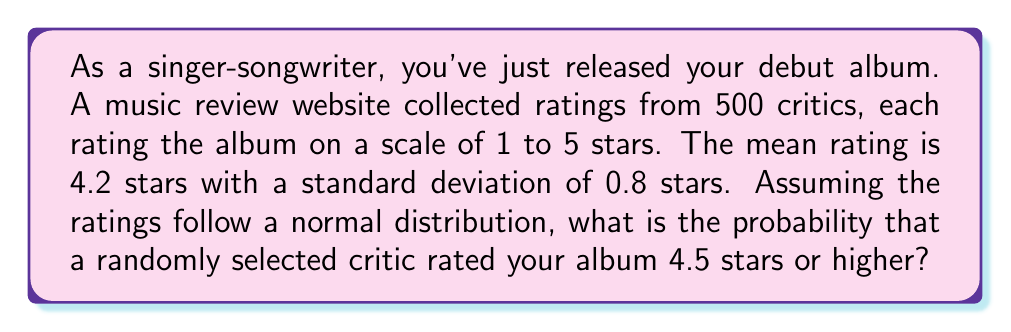Solve this math problem. To solve this problem, we'll use the properties of the normal distribution and the z-score formula. Here's a step-by-step approach:

1. Identify the given information:
   - Mean (μ) = 4.2 stars
   - Standard deviation (σ) = 0.8 stars
   - We want to find P(X ≥ 4.5), where X is the rating

2. Calculate the z-score for 4.5 stars:
   $$z = \frac{x - \mu}{\sigma} = \frac{4.5 - 4.2}{0.8} = 0.375$$

3. Use the standard normal distribution table or a calculator to find the area to the right of z = 0.375:
   P(Z > 0.375) = 1 - P(Z < 0.375)
   
   From the standard normal table:
   P(Z < 0.375) ≈ 0.6462

   Therefore:
   P(Z > 0.375) = 1 - 0.6462 = 0.3538

4. This probability (0.3538) represents the chance that a randomly selected critic rated your album 4.5 stars or higher.
Answer: 0.3538 or approximately 35.38% 